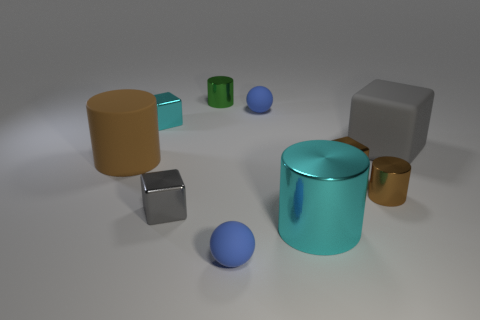Subtract 1 cylinders. How many cylinders are left? 3 Subtract all cubes. How many objects are left? 6 Subtract 0 cyan balls. How many objects are left? 10 Subtract all small yellow rubber spheres. Subtract all small things. How many objects are left? 3 Add 8 small blue matte balls. How many small blue matte balls are left? 10 Add 3 small cyan cubes. How many small cyan cubes exist? 4 